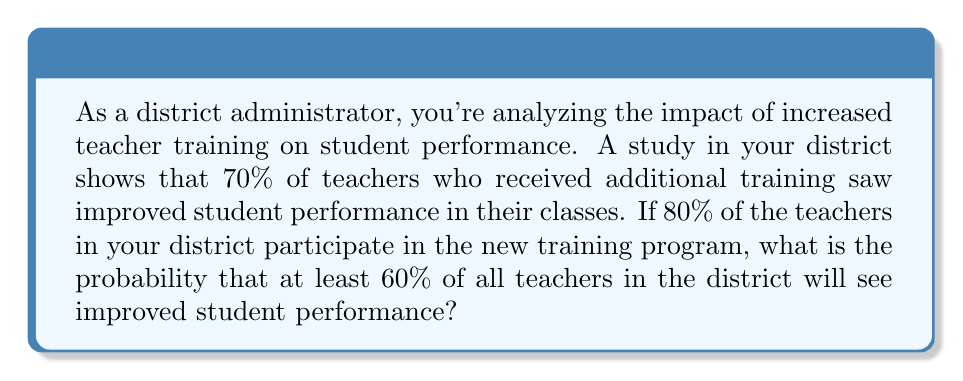Give your solution to this math problem. Let's approach this step-by-step:

1) Let $X$ be the number of teachers who see improved student performance.

2) The total number of teachers is not given, so let's assume there are $n$ teachers in the district.

3) We know that:
   - 80% of teachers participate in the training: $0.8n$
   - 70% of trained teachers see improvement: $0.7 * 0.8n = 0.56n$

4) The question asks for the probability that at least 60% of all teachers see improvement. This means we're looking for $P(X \geq 0.6n)$.

5) We can model this as a binomial distribution:
   $X \sim B(n, 0.56)$

6) We want to find:
   $P(X \geq 0.6n) = 1 - P(X < 0.6n)$

7) For large $n$, we can approximate this using the normal distribution:
   $X \approx N(np, np(1-p))$
   where $p = 0.56$

8) Standardizing:
   $$Z = \frac{X - np}{\sqrt{np(1-p)}} = \frac{0.6n - 0.56n}{\sqrt{0.56n(1-0.56)}}$$
   $$= \frac{0.04n}{\sqrt{0.2464n}} = \frac{0.04\sqrt{n}}{\sqrt{0.2464}} = 0.08\sqrt{n}$$

9) Therefore:
   $P(X \geq 0.6n) = 1 - P(Z < 0.08\sqrt{n})$

10) For large $n$, $0.08\sqrt{n}$ will be greater than 3, making $P(Z < 0.08\sqrt{n})$ very close to 1.

11) Thus, $P(X \geq 0.6n)$ will be very close to 0.
Answer: The probability is approximately 0 for a large number of teachers. 